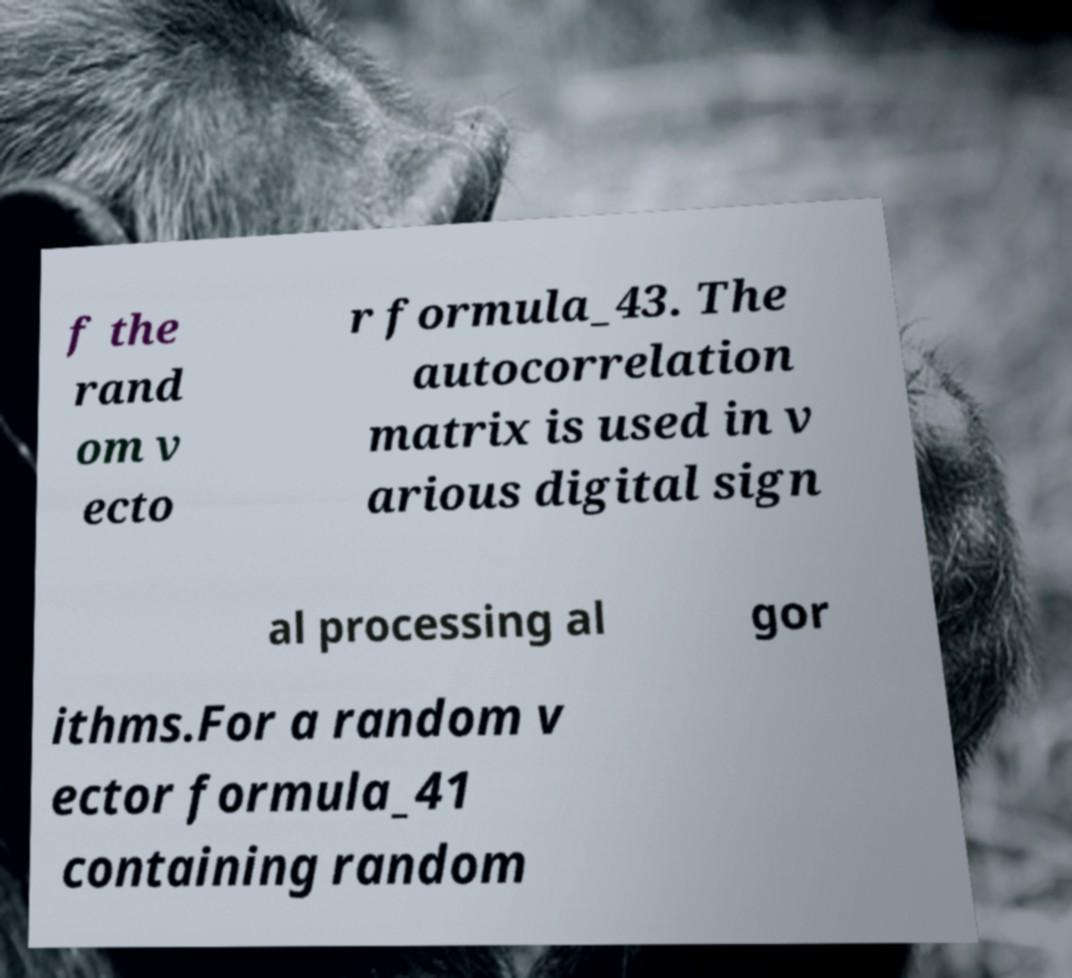I need the written content from this picture converted into text. Can you do that? f the rand om v ecto r formula_43. The autocorrelation matrix is used in v arious digital sign al processing al gor ithms.For a random v ector formula_41 containing random 